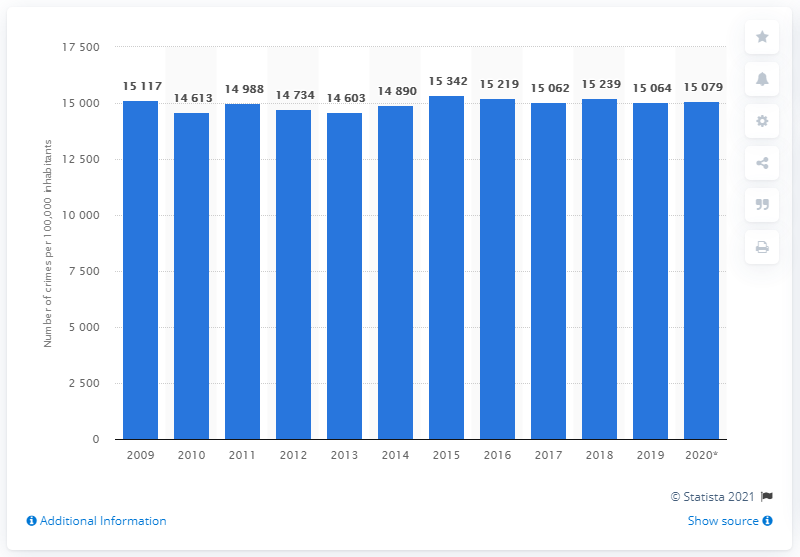In what year was Sweden's highest crime rate? According to the bar graph, Sweden's highest crime rate occurred in the year 2015, with a reported number of crimes per 100,000 inhabitants reaching 15,342. 